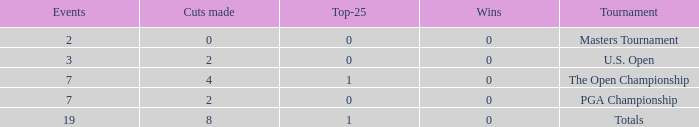What is the Wins of the Top-25 of 1 and 7 Events? 0.0. 